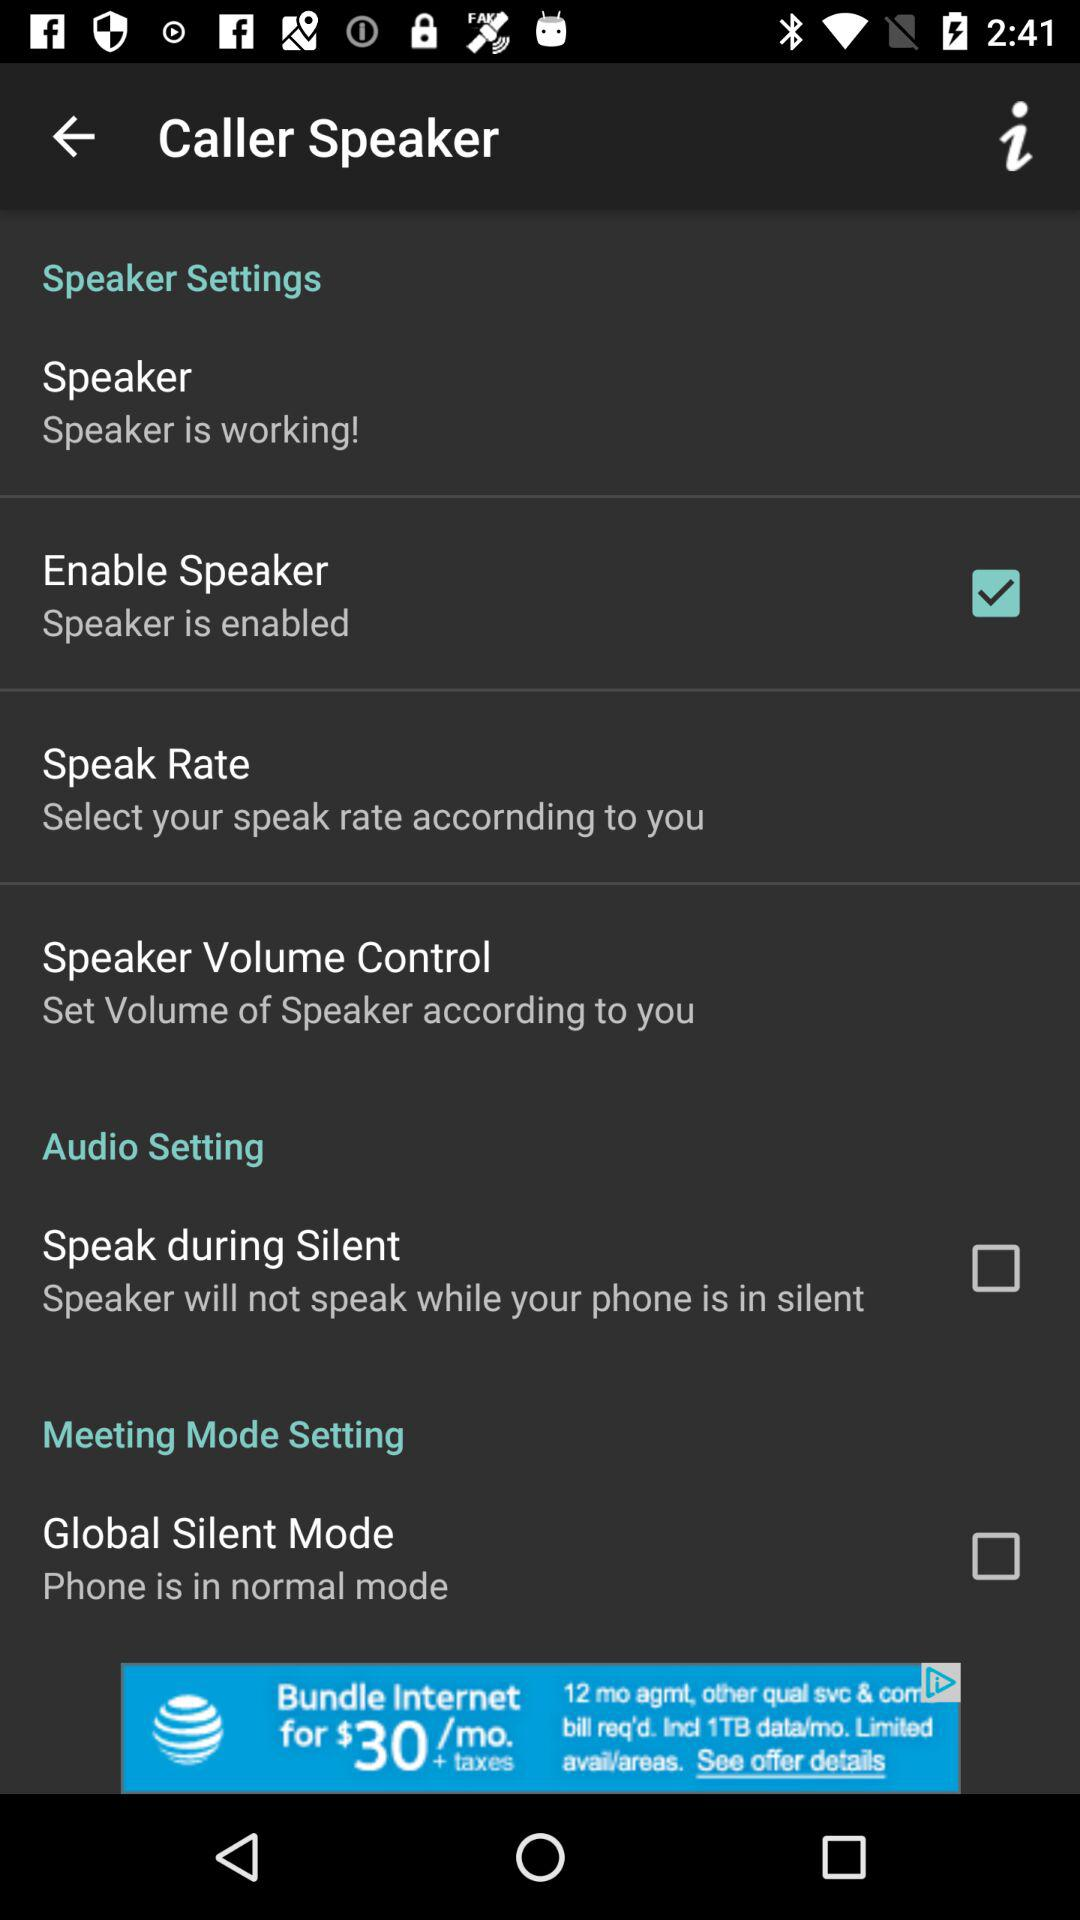What is the status of "Global Silent Mode"? The status is "off". 